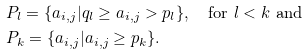<formula> <loc_0><loc_0><loc_500><loc_500>& P _ { l } = \{ a _ { i , j } | q _ { l } \geq a _ { i , j } > p _ { l } \} , \quad \text {for $l<k$ and} \\ & P _ { k } = \{ a _ { i , j } | a _ { i , j } \geq p _ { k } \} .</formula> 